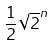<formula> <loc_0><loc_0><loc_500><loc_500>\frac { 1 } { 2 } \sqrt { 2 } ^ { n }</formula> 